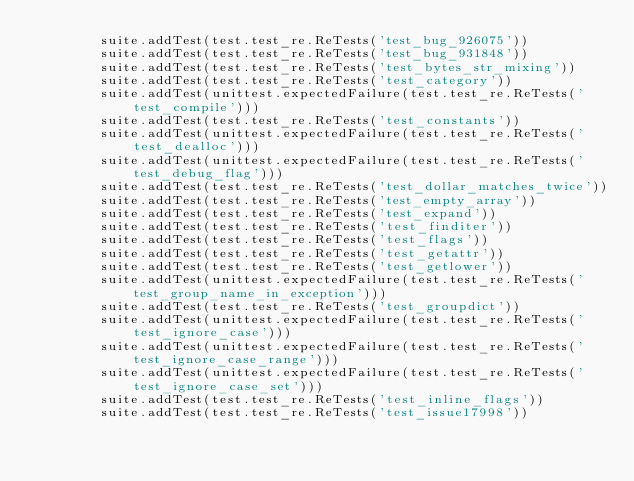<code> <loc_0><loc_0><loc_500><loc_500><_Python_>        suite.addTest(test.test_re.ReTests('test_bug_926075'))
        suite.addTest(test.test_re.ReTests('test_bug_931848'))
        suite.addTest(test.test_re.ReTests('test_bytes_str_mixing'))
        suite.addTest(test.test_re.ReTests('test_category'))
        suite.addTest(unittest.expectedFailure(test.test_re.ReTests('test_compile')))
        suite.addTest(test.test_re.ReTests('test_constants'))
        suite.addTest(unittest.expectedFailure(test.test_re.ReTests('test_dealloc')))
        suite.addTest(unittest.expectedFailure(test.test_re.ReTests('test_debug_flag')))
        suite.addTest(test.test_re.ReTests('test_dollar_matches_twice'))
        suite.addTest(test.test_re.ReTests('test_empty_array'))
        suite.addTest(test.test_re.ReTests('test_expand'))
        suite.addTest(test.test_re.ReTests('test_finditer'))
        suite.addTest(test.test_re.ReTests('test_flags'))
        suite.addTest(test.test_re.ReTests('test_getattr'))
        suite.addTest(test.test_re.ReTests('test_getlower'))
        suite.addTest(unittest.expectedFailure(test.test_re.ReTests('test_group_name_in_exception')))
        suite.addTest(test.test_re.ReTests('test_groupdict'))
        suite.addTest(unittest.expectedFailure(test.test_re.ReTests('test_ignore_case')))
        suite.addTest(unittest.expectedFailure(test.test_re.ReTests('test_ignore_case_range')))
        suite.addTest(unittest.expectedFailure(test.test_re.ReTests('test_ignore_case_set')))
        suite.addTest(test.test_re.ReTests('test_inline_flags'))
        suite.addTest(test.test_re.ReTests('test_issue17998'))</code> 